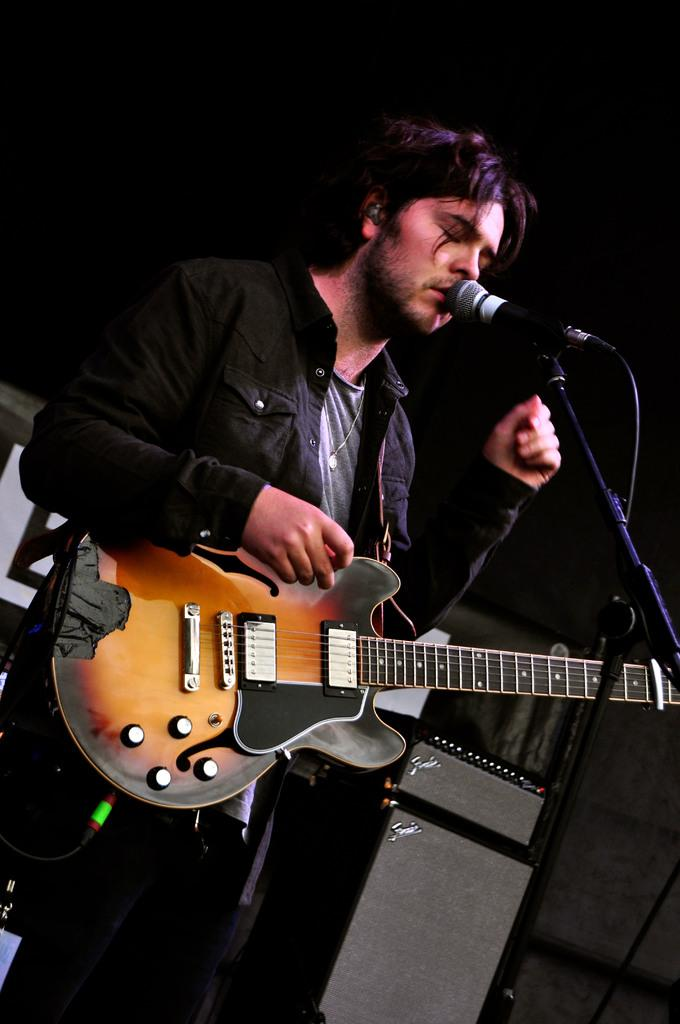What is the man in the image doing? The man is singing on a microphone. What instrument is the man holding in the image? The man is holding a guitar. What color are the man's trousers in the image? The provided facts do not mention the color of the man's trousers, so we cannot determine the color from the image. How long does the man sing for in the image? The provided facts do not mention the duration of the man's singing, so we cannot determine the length of time from the image. 